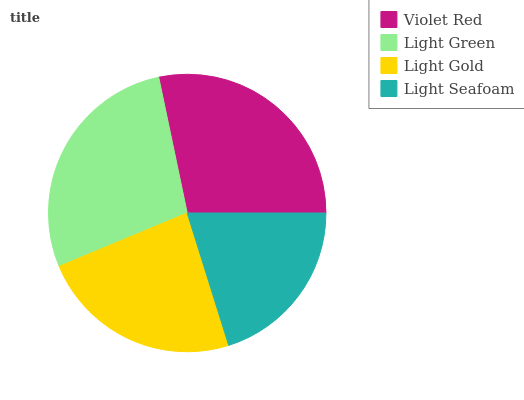Is Light Seafoam the minimum?
Answer yes or no. Yes. Is Violet Red the maximum?
Answer yes or no. Yes. Is Light Green the minimum?
Answer yes or no. No. Is Light Green the maximum?
Answer yes or no. No. Is Violet Red greater than Light Green?
Answer yes or no. Yes. Is Light Green less than Violet Red?
Answer yes or no. Yes. Is Light Green greater than Violet Red?
Answer yes or no. No. Is Violet Red less than Light Green?
Answer yes or no. No. Is Light Green the high median?
Answer yes or no. Yes. Is Light Gold the low median?
Answer yes or no. Yes. Is Light Gold the high median?
Answer yes or no. No. Is Violet Red the low median?
Answer yes or no. No. 